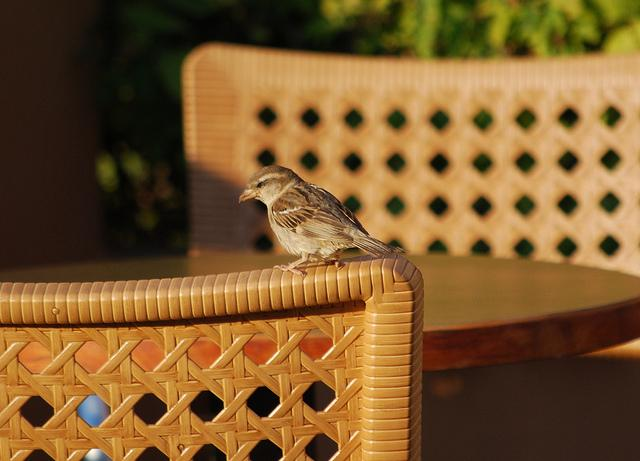What materials are the chairs made of? Please explain your reasoning. bamboo. The material is woodlike.  the material is woven. 